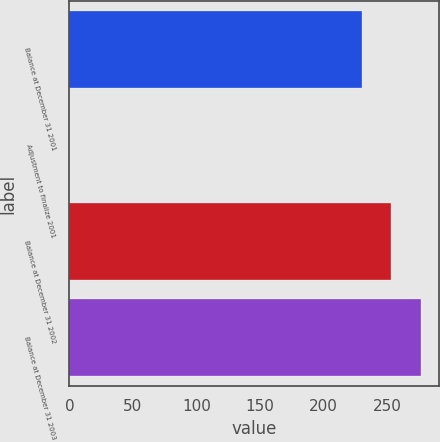Convert chart to OTSL. <chart><loc_0><loc_0><loc_500><loc_500><bar_chart><fcel>Balance at December 31 2001<fcel>Adjustment to finalize 2001<fcel>Balance at December 31 2002<fcel>Balance at December 31 2003<nl><fcel>230<fcel>0.1<fcel>253.51<fcel>277.02<nl></chart> 